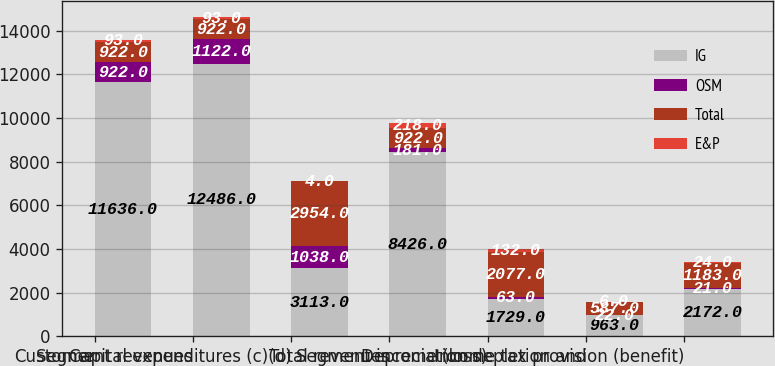Convert chart to OTSL. <chart><loc_0><loc_0><loc_500><loc_500><stacked_bar_chart><ecel><fcel>Customer<fcel>Segment revenues<fcel>Capital expenditures (c)(d)<fcel>Total revenues<fcel>Segment income (loss)<fcel>Depreciation depletion and<fcel>Income tax provision (benefit)<nl><fcel>IG<fcel>11636<fcel>12486<fcel>3113<fcel>8426<fcel>1729<fcel>963<fcel>2172<nl><fcel>OSM<fcel>922<fcel>1122<fcel>1038<fcel>181<fcel>63<fcel>22<fcel>21<nl><fcel>Total<fcel>922<fcel>922<fcel>2954<fcel>922<fcel>2077<fcel>587<fcel>1183<nl><fcel>E&P<fcel>93<fcel>93<fcel>4<fcel>218<fcel>132<fcel>6<fcel>24<nl></chart> 